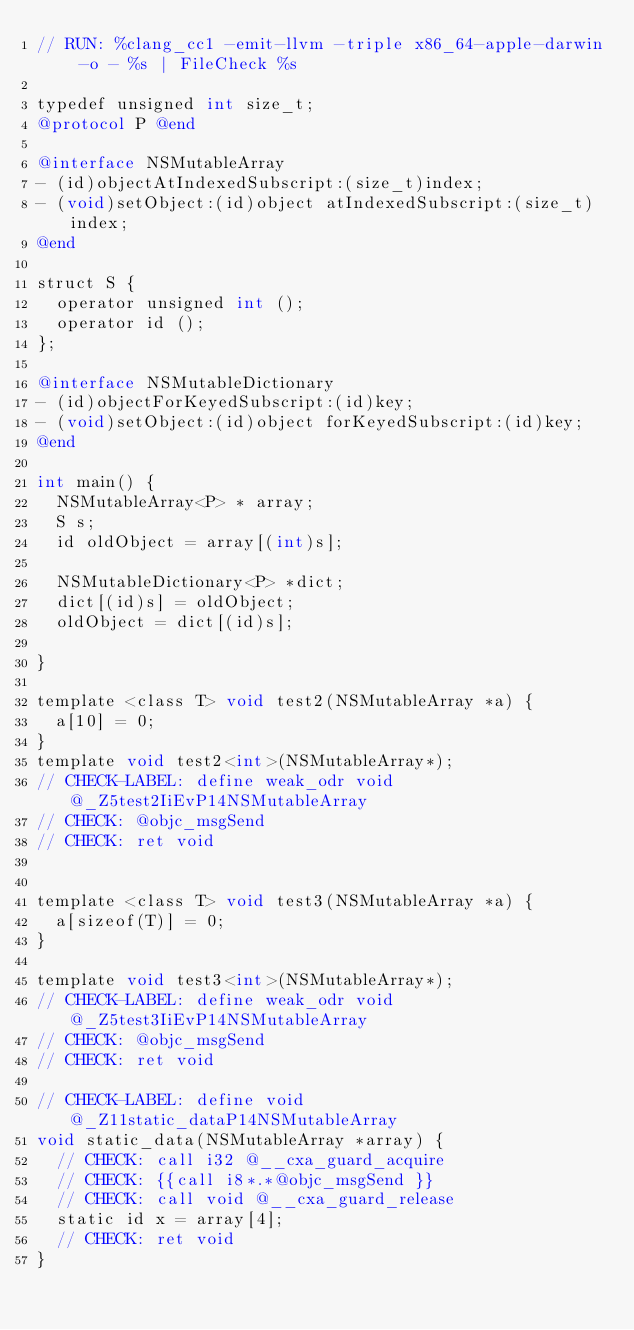Convert code to text. <code><loc_0><loc_0><loc_500><loc_500><_ObjectiveC_>// RUN: %clang_cc1 -emit-llvm -triple x86_64-apple-darwin -o - %s | FileCheck %s

typedef unsigned int size_t;
@protocol P @end

@interface NSMutableArray
- (id)objectAtIndexedSubscript:(size_t)index;
- (void)setObject:(id)object atIndexedSubscript:(size_t)index;
@end

struct S {
  operator unsigned int ();
  operator id ();
};

@interface NSMutableDictionary
- (id)objectForKeyedSubscript:(id)key;
- (void)setObject:(id)object forKeyedSubscript:(id)key;
@end

int main() {
  NSMutableArray<P> * array;
  S s;
  id oldObject = array[(int)s];

  NSMutableDictionary<P> *dict;
  dict[(id)s] = oldObject;
  oldObject = dict[(id)s];

}

template <class T> void test2(NSMutableArray *a) {
  a[10] = 0;
}
template void test2<int>(NSMutableArray*);
// CHECK-LABEL: define weak_odr void @_Z5test2IiEvP14NSMutableArray
// CHECK: @objc_msgSend 
// CHECK: ret void


template <class T> void test3(NSMutableArray *a) {
  a[sizeof(T)] = 0;
}

template void test3<int>(NSMutableArray*);
// CHECK-LABEL: define weak_odr void @_Z5test3IiEvP14NSMutableArray
// CHECK: @objc_msgSend
// CHECK: ret void

// CHECK-LABEL: define void @_Z11static_dataP14NSMutableArray
void static_data(NSMutableArray *array) {
  // CHECK: call i32 @__cxa_guard_acquire
  // CHECK: {{call i8*.*@objc_msgSend }}
  // CHECK: call void @__cxa_guard_release
  static id x = array[4];
  // CHECK: ret void
}
</code> 